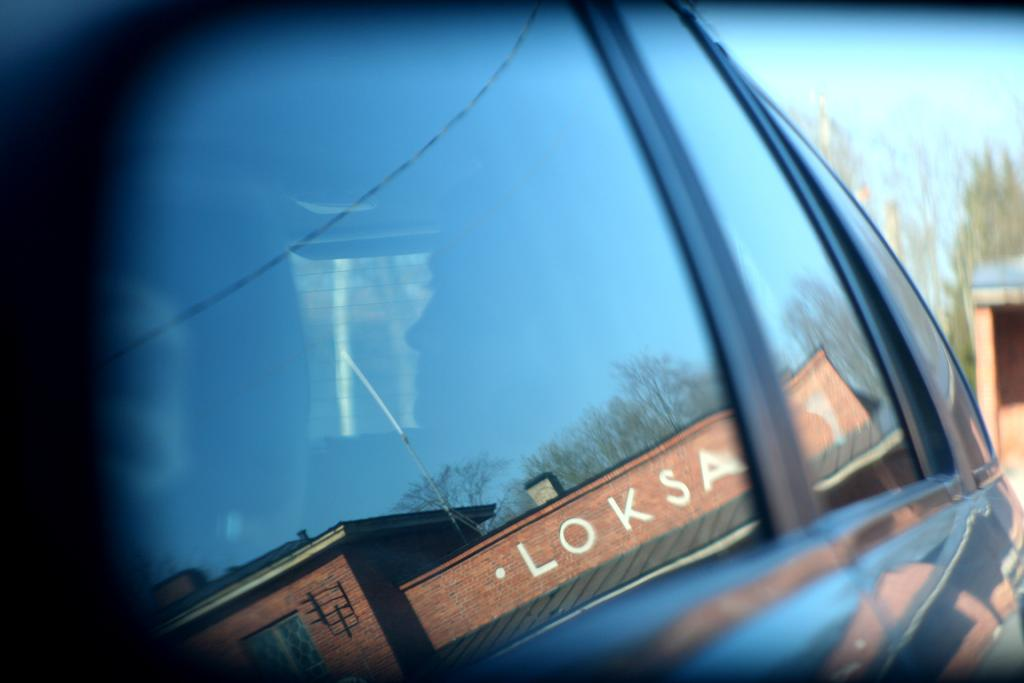What is happening in the image? There is a person inside a vehicle in the image. Where is the vehicle located in the image? The vehicle is in the center of the image. What can be seen reflecting in the glass of the vehicle? A building is reflecting in the glass of the vehicle. What type of natural environment is visible in the background of the image? There are trees in the background of the image. What type of structure can be seen in the background of the image? There is a shed in the background of the image. What is visible in the sky in the background of the image? The sky is visible in the background of the image. How does the person inside the vehicle exchange comfort with the sleet in the image? There is no sleet present in the image, and therefore no exchange of comfort can be observed. 